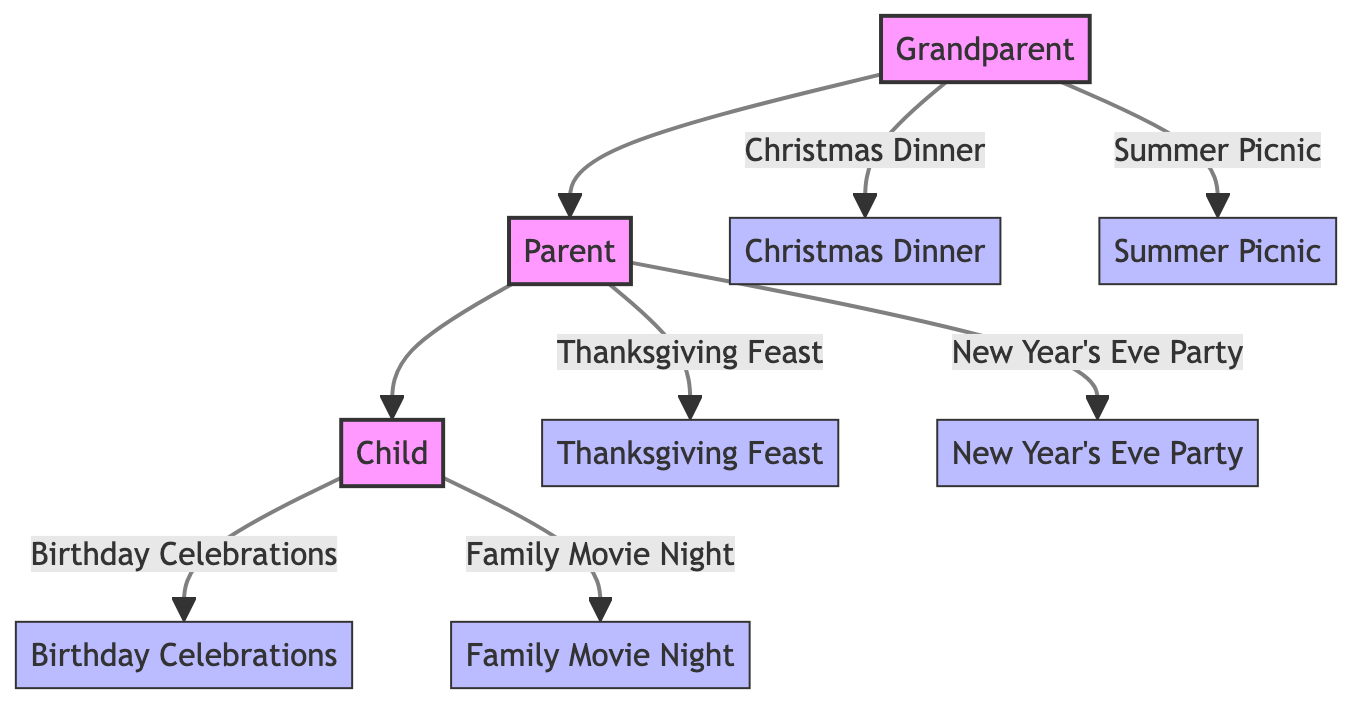What are two traditions from the Grandparent generation? The diagram shows two traditions originating from the Grandparent generation: Christmas Dinner and Summer Picnic. These are explicitly listed in the diagram under the Grandparent node.
Answer: Christmas Dinner, Summer Picnic How many generations are represented in the diagram? The diagram includes three generations: Grandparent, Parent, and Child. This information can be counted from the separate generation nodes displayed in the diagram.
Answer: 3 What is the relationship between the Parent and Child generations? The diagram shows a direct connection from the Parent node to the Child node, indicating that the Child is a descendant of the Parent. This relationship is structured hierarchically in the diagram.
Answer: Child Which tradition includes a family football game? The tradition that includes a family football game is the Thanksgiving Feast, as stated in the description provided for that specific tradition under the Parent generation.
Answer: Thanksgiving Feast How many traditions does the Child generation have? The Child generation has two distinct traditions: Birthday Celebrations and Family Movie Night. This information is noted under the Child node in the diagram.
Answer: 2 Which traditions were celebrated by the Grandparent generation? The Grandparent generation celebrated two traditions: Christmas Dinner and Summer Picnic. This information can be found directly in the description of the Grandparent node within the diagram.
Answer: Christmas Dinner, Summer Picnic Which celebration is associated with fireworks? The New Year's Eve Party is associated with fireworks, as indicated in the description provided for that specific tradition under the Parent generation.
Answer: New Year's Eve Party What activity is included in the Family Movie Night? The Family Movie Night includes watching a movie together at home with popcorn and snacks. This detail is highlighted in the description of the tradition under the Child generation.
Answer: Watching a movie 